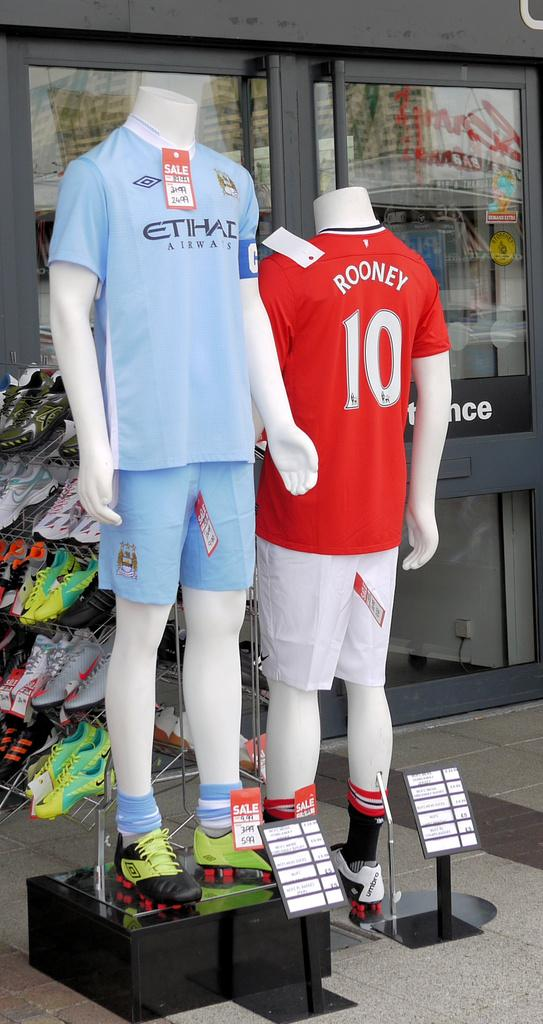<image>
Present a compact description of the photo's key features. ROONEY 10 is written on the back of a jersey being displayed on a mannequi. 